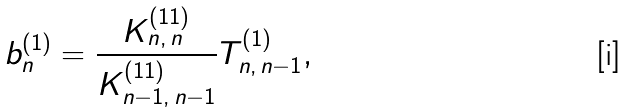Convert formula to latex. <formula><loc_0><loc_0><loc_500><loc_500>b ^ { ( 1 ) } _ { n } = \frac { K ^ { ( 1 1 ) } _ { n , \, n } } { K ^ { ( 1 1 ) } _ { n - 1 , \, n - 1 } } T _ { n , \, n - 1 } ^ { ( 1 ) } ,</formula> 